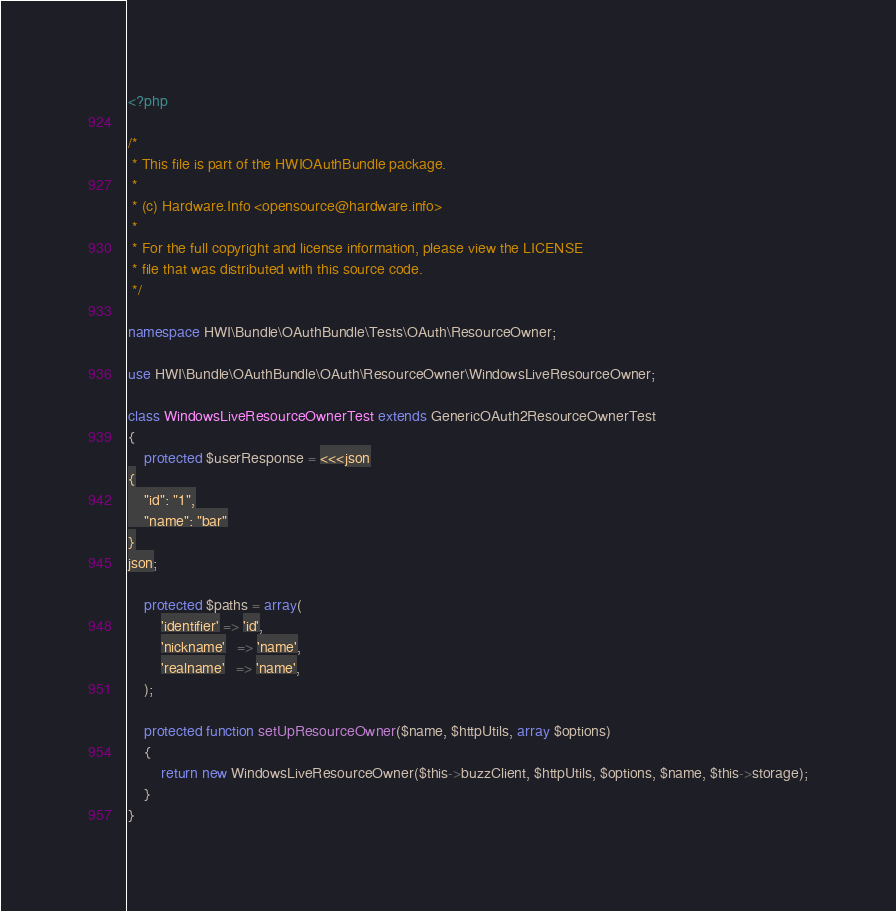Convert code to text. <code><loc_0><loc_0><loc_500><loc_500><_PHP_><?php

/*
 * This file is part of the HWIOAuthBundle package.
 *
 * (c) Hardware.Info <opensource@hardware.info>
 *
 * For the full copyright and license information, please view the LICENSE
 * file that was distributed with this source code.
 */

namespace HWI\Bundle\OAuthBundle\Tests\OAuth\ResourceOwner;

use HWI\Bundle\OAuthBundle\OAuth\ResourceOwner\WindowsLiveResourceOwner;

class WindowsLiveResourceOwnerTest extends GenericOAuth2ResourceOwnerTest
{
    protected $userResponse = <<<json
{
    "id": "1",
    "name": "bar"
}
json;

    protected $paths = array(
        'identifier' => 'id',
        'nickname'   => 'name',
        'realname'   => 'name',
    );

    protected function setUpResourceOwner($name, $httpUtils, array $options)
    {
        return new WindowsLiveResourceOwner($this->buzzClient, $httpUtils, $options, $name, $this->storage);
    }
}
</code> 